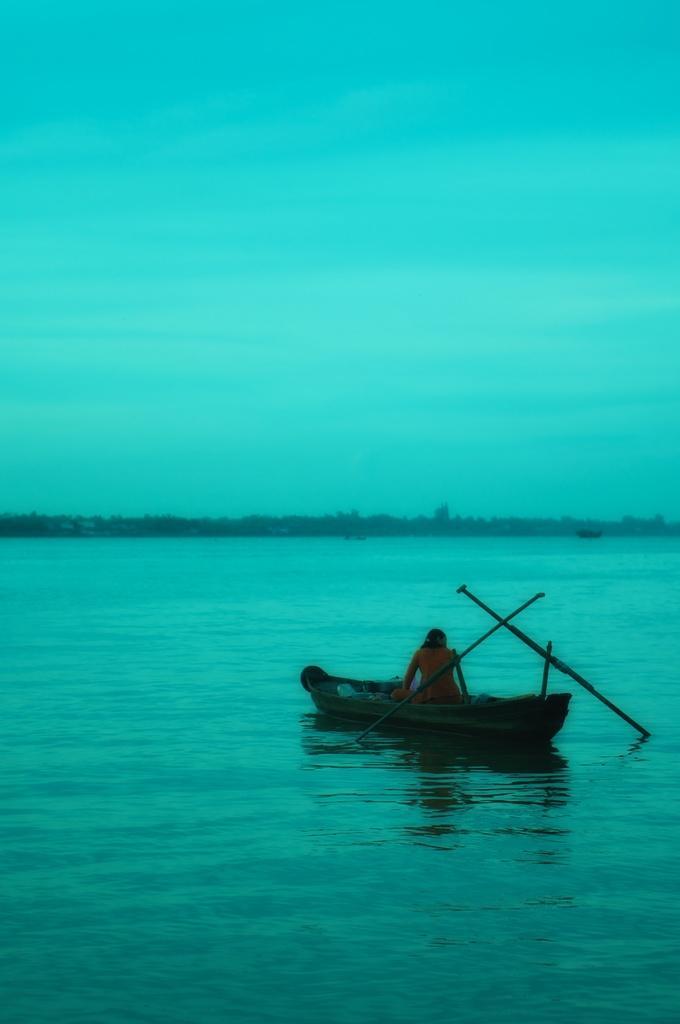Can you describe this image briefly? In this image I can see a boat on the water and I can see a person sitting in the boat. The water is in green color, background the sky is in blue color. 